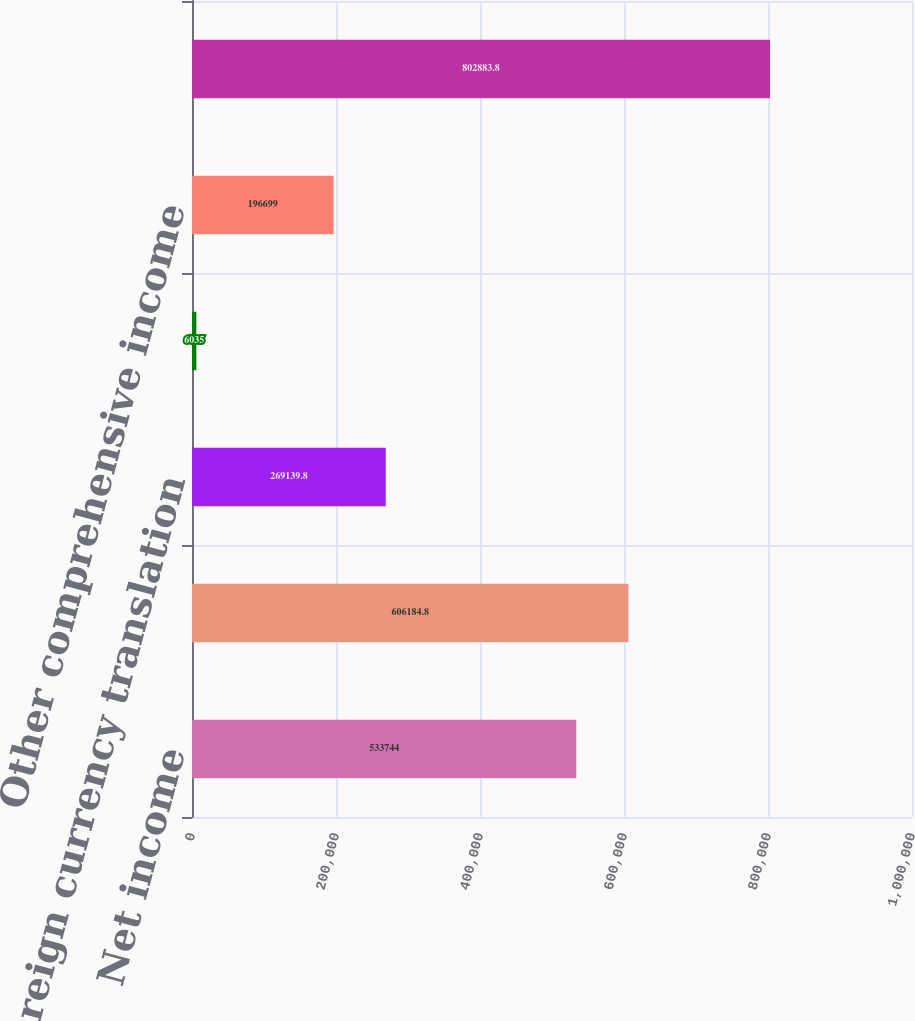<chart> <loc_0><loc_0><loc_500><loc_500><bar_chart><fcel>Net income<fcel>Net income attributable to LKQ<fcel>Foreign currency translation<fcel>Net change in unrealized<fcel>Other comprehensive income<fcel>Comprehensive income<nl><fcel>533744<fcel>606185<fcel>269140<fcel>6035<fcel>196699<fcel>802884<nl></chart> 